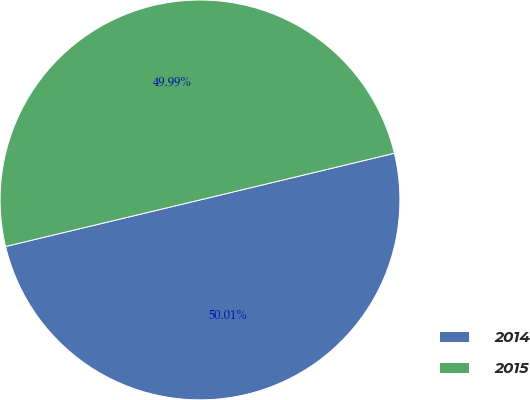<chart> <loc_0><loc_0><loc_500><loc_500><pie_chart><fcel>2014<fcel>2015<nl><fcel>50.01%<fcel>49.99%<nl></chart> 